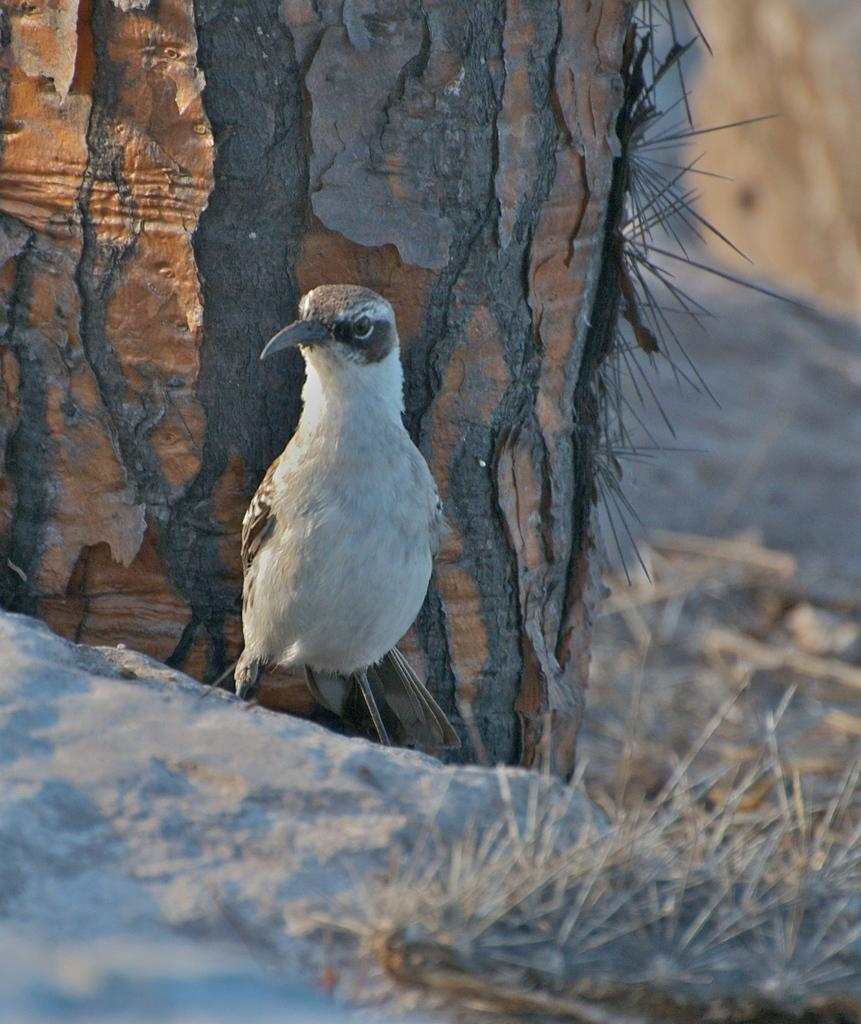What animal is standing on the ground in the image? There is a bird standing on the ground in the image. What can be seen in the background of the image? There is a tree and grass in the background of the image. How is the background of the image depicted? The background of the image is blurred. What song is the bird singing in the image? There is no indication in the image that the bird is singing a song. 